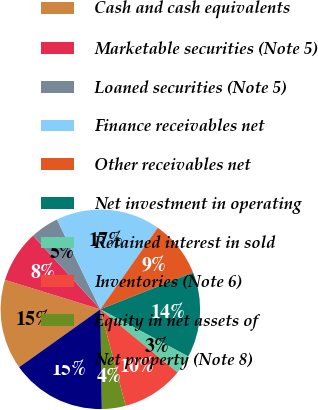<chart> <loc_0><loc_0><loc_500><loc_500><pie_chart><fcel>Cash and cash equivalents<fcel>Marketable securities (Note 5)<fcel>Loaned securities (Note 5)<fcel>Finance receivables net<fcel>Other receivables net<fcel>Net investment in operating<fcel>Retained interest in sold<fcel>Inventories (Note 6)<fcel>Equity in net assets of<fcel>Net property (Note 8)<nl><fcel>14.62%<fcel>8.46%<fcel>4.62%<fcel>16.92%<fcel>9.23%<fcel>13.85%<fcel>3.08%<fcel>10.0%<fcel>3.85%<fcel>15.38%<nl></chart> 